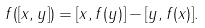<formula> <loc_0><loc_0><loc_500><loc_500>f ( [ x , y ] ) = [ x , f ( y ) ] - [ y , f ( x ) ] .</formula> 